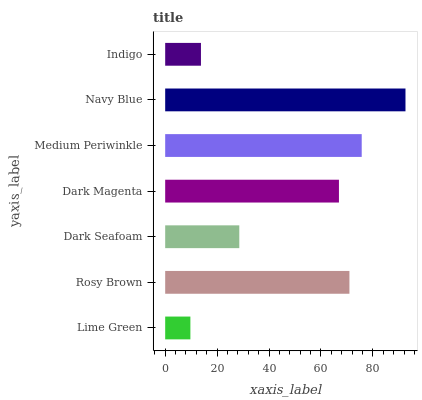Is Lime Green the minimum?
Answer yes or no. Yes. Is Navy Blue the maximum?
Answer yes or no. Yes. Is Rosy Brown the minimum?
Answer yes or no. No. Is Rosy Brown the maximum?
Answer yes or no. No. Is Rosy Brown greater than Lime Green?
Answer yes or no. Yes. Is Lime Green less than Rosy Brown?
Answer yes or no. Yes. Is Lime Green greater than Rosy Brown?
Answer yes or no. No. Is Rosy Brown less than Lime Green?
Answer yes or no. No. Is Dark Magenta the high median?
Answer yes or no. Yes. Is Dark Magenta the low median?
Answer yes or no. Yes. Is Dark Seafoam the high median?
Answer yes or no. No. Is Medium Periwinkle the low median?
Answer yes or no. No. 